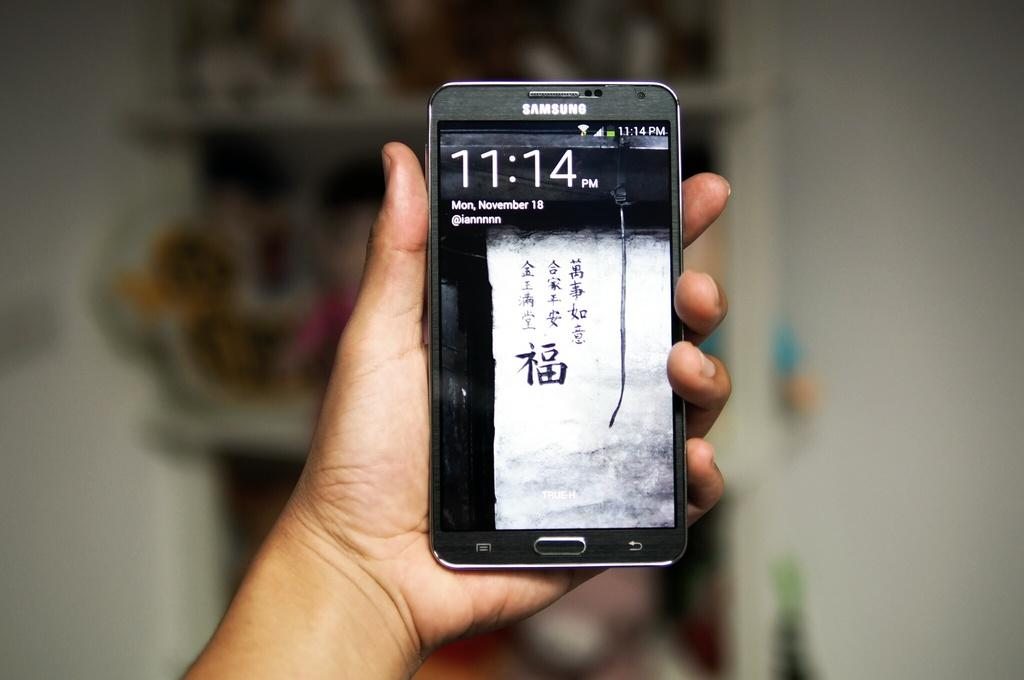<image>
Give a short and clear explanation of the subsequent image. A samsung phone that shows the time of 11:14 pm. 